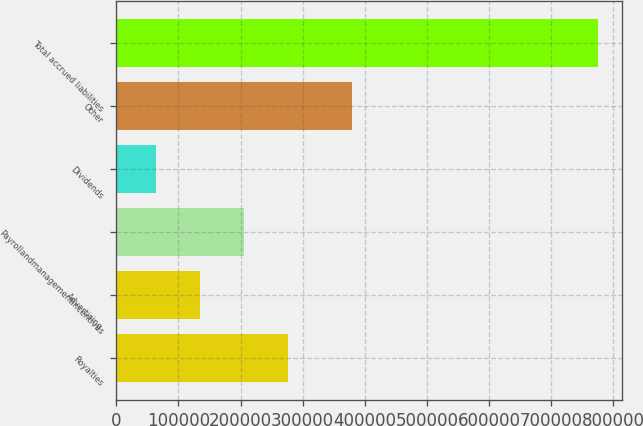<chart> <loc_0><loc_0><loc_500><loc_500><bar_chart><fcel>Royalties<fcel>Advertising<fcel>Payrollandmanagementincentives<fcel>Dividends<fcel>Other<fcel>Total accrued liabilities<nl><fcel>277262<fcel>134755<fcel>206009<fcel>63501<fcel>379974<fcel>776039<nl></chart> 